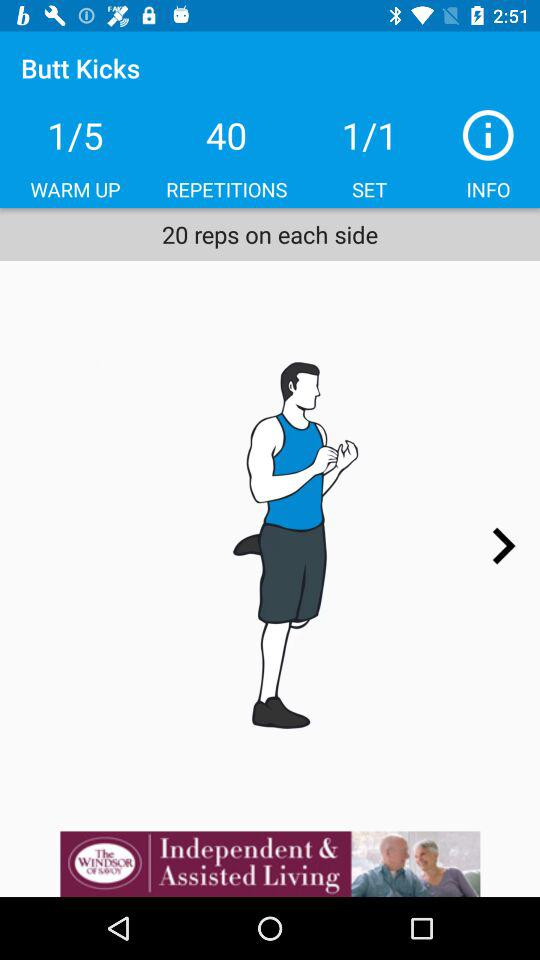How many sets are there?
Answer the question using a single word or phrase. 1 